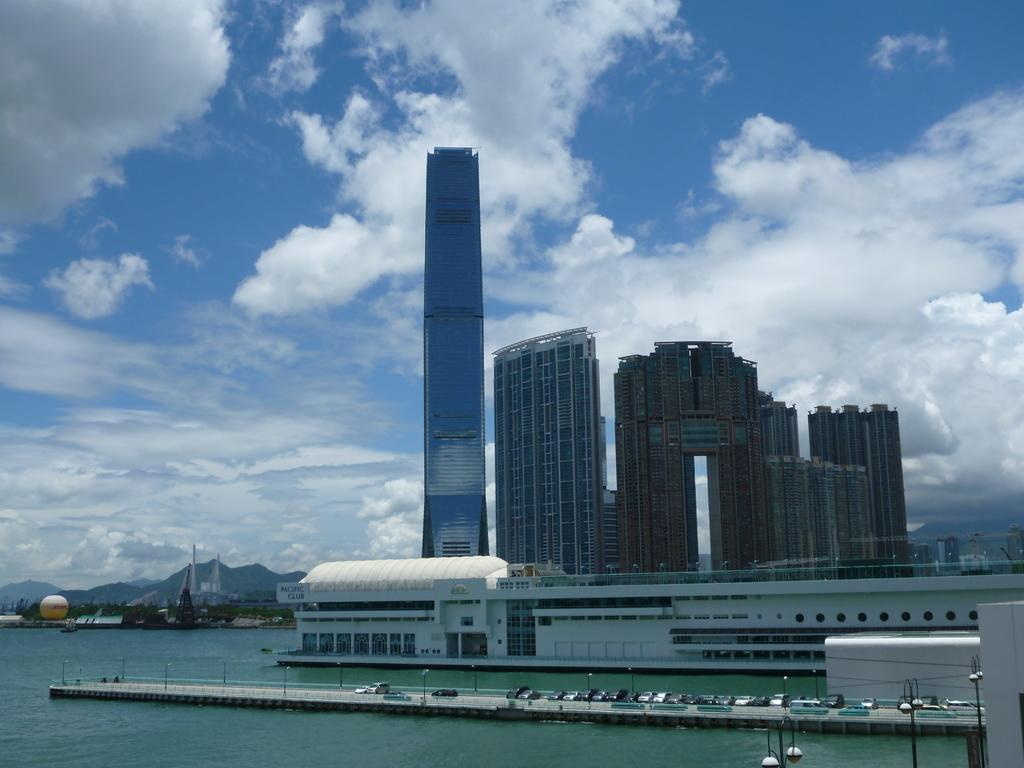What type of structures are located near the water in the image? There are buildings beside the water in the image. What can be seen crossing the water in the image? There is a bridge with vehicles in the image. What is visible in the distance behind the water? There are hills and buildings in the background, as well as the sky with clouds. How many geese are flying over the bridge in the image? There are no geese present in the image; it features a bridge with vehicles and no birds are visible. What type of net is being used by the laborer in the image? There is no laborer or net present in the image. 